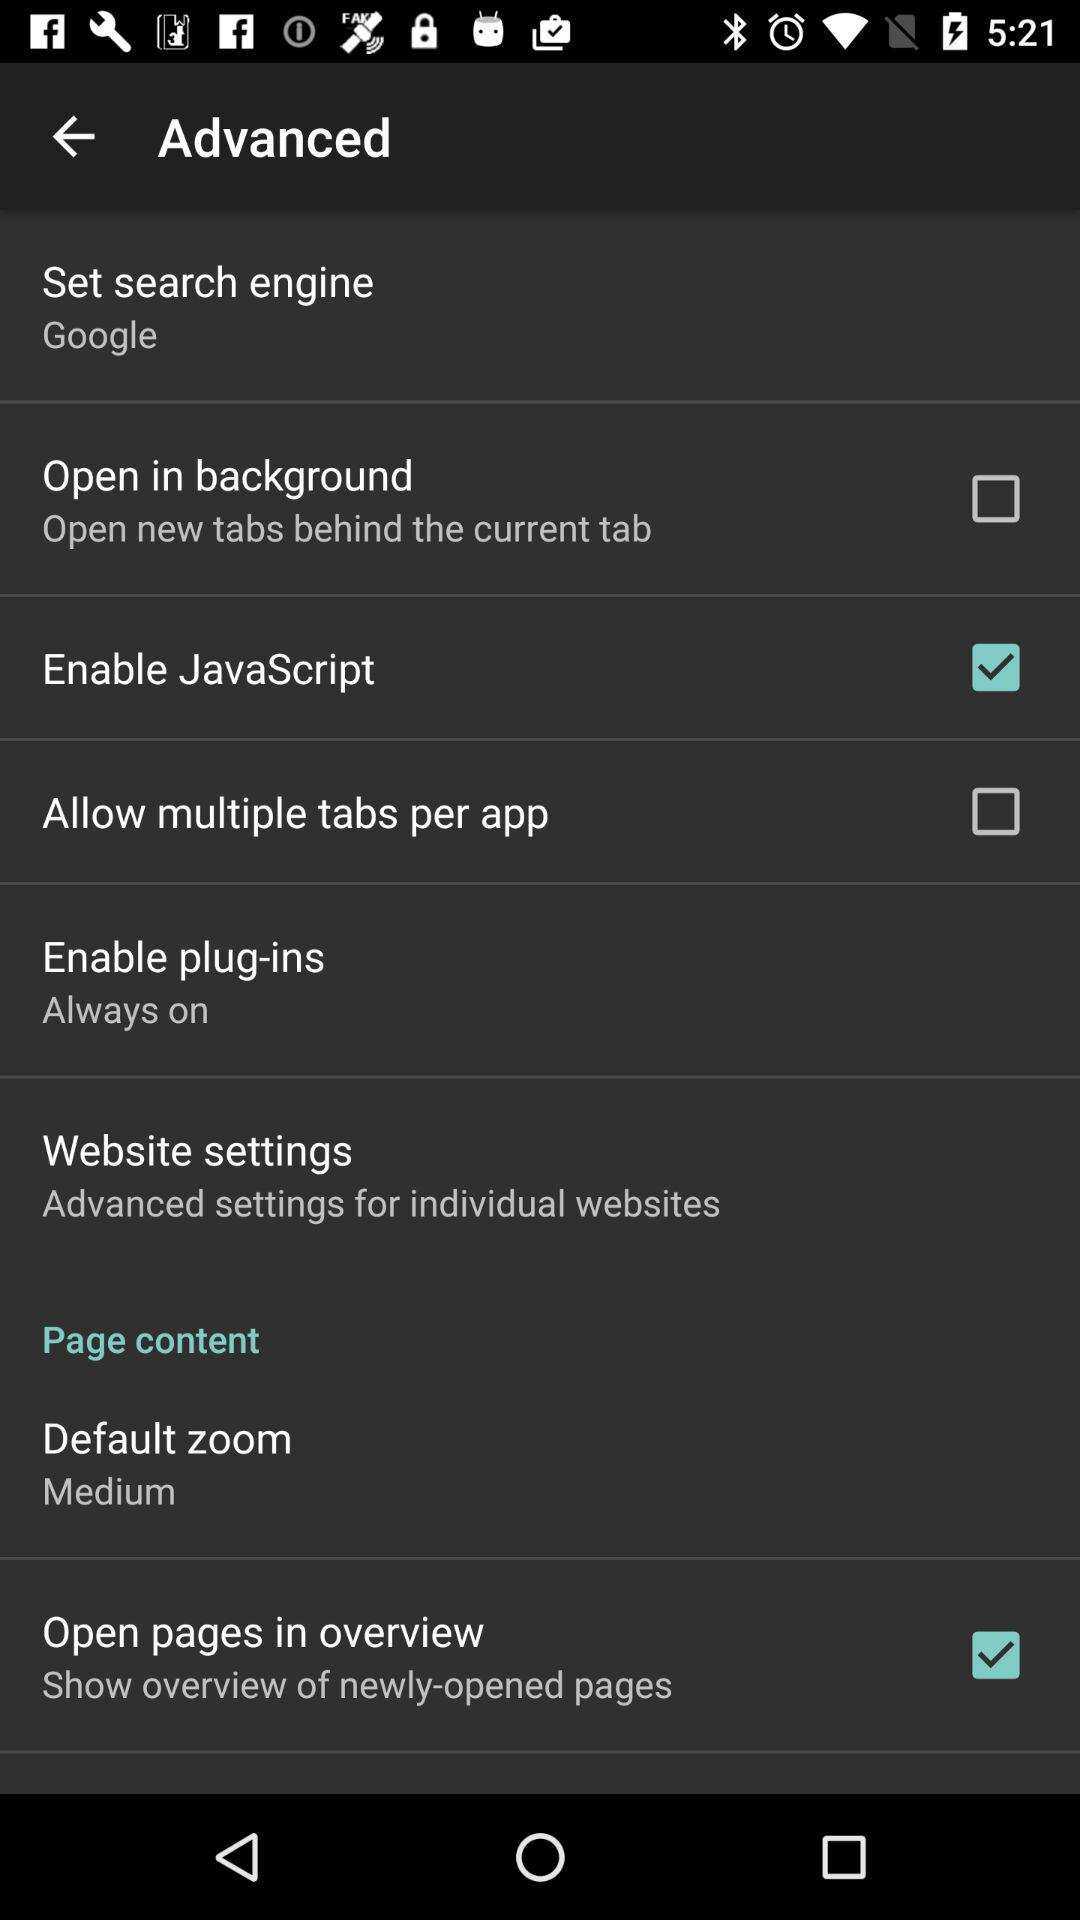What is the setting for default zoom? The setting for default zoom is "Medium". 